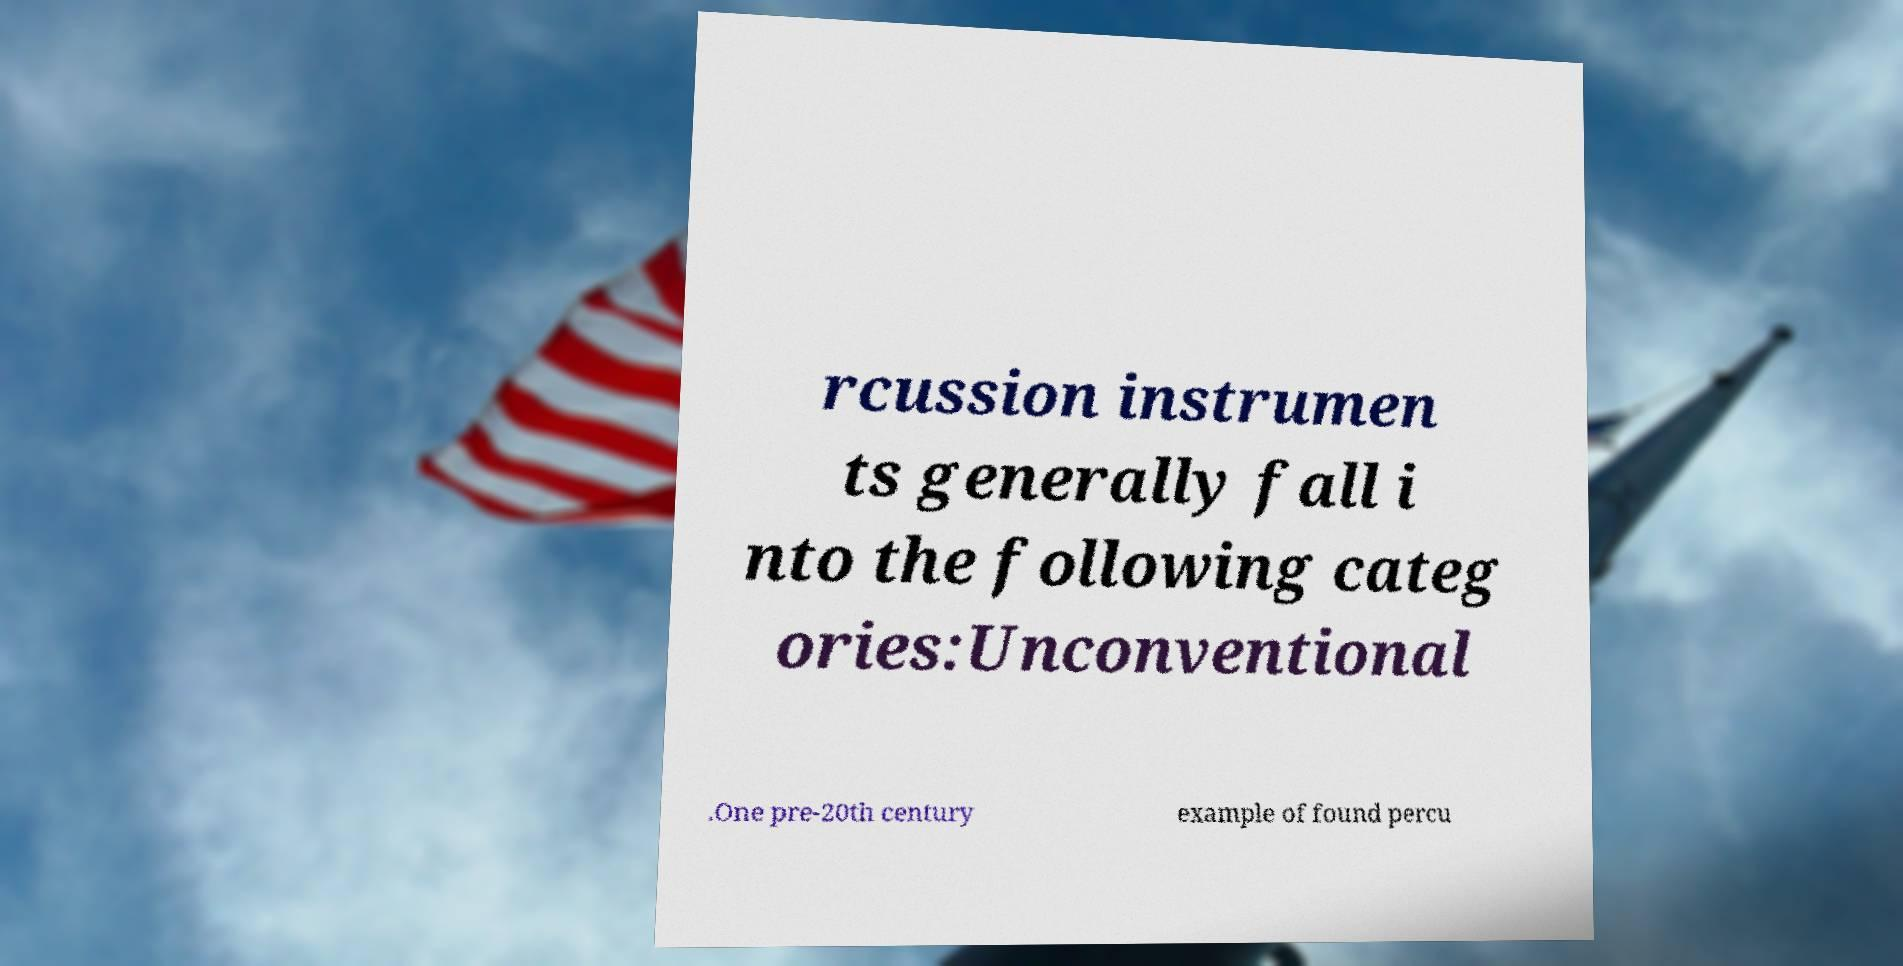Could you extract and type out the text from this image? rcussion instrumen ts generally fall i nto the following categ ories:Unconventional .One pre-20th century example of found percu 